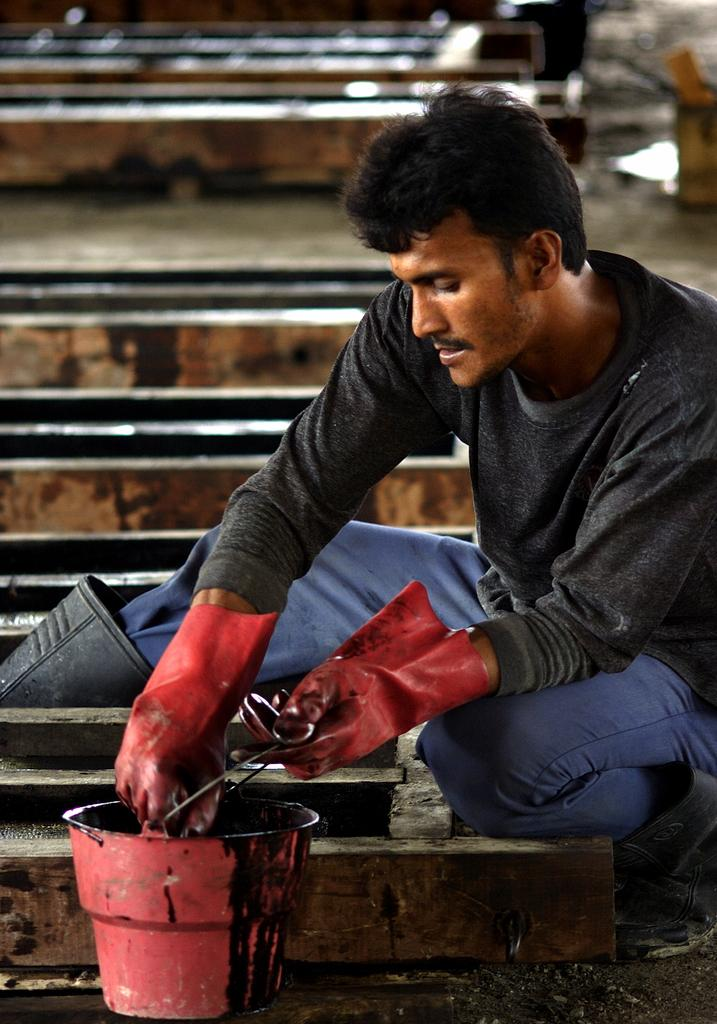What type of structure is present in the image? There are stairs in the image. What object can be seen near the stairs? There is a pot in the image. Who is present in the image? There is a man in the image. What is the man wearing? The man is wearing a black jacket. What is the texture of the example in the image? There is no example present in the image, and therefore no texture can be described. What type of vessel is used to hold the man in the image? There is no vessel holding the man in the image; he is standing on the ground. 